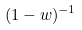Convert formula to latex. <formula><loc_0><loc_0><loc_500><loc_500>( 1 - w ) ^ { - 1 }</formula> 